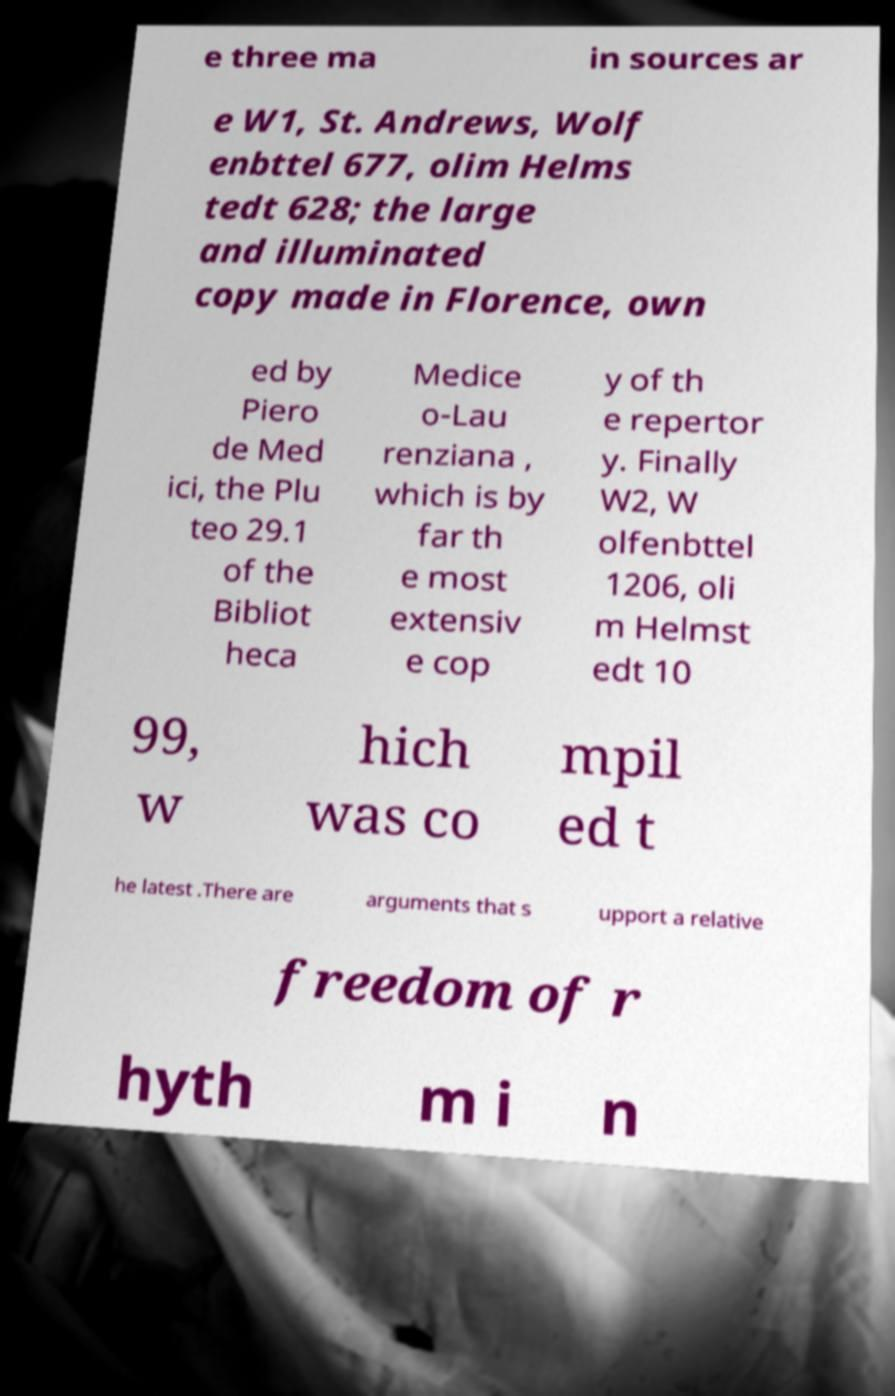Could you assist in decoding the text presented in this image and type it out clearly? e three ma in sources ar e W1, St. Andrews, Wolf enbttel 677, olim Helms tedt 628; the large and illuminated copy made in Florence, own ed by Piero de Med ici, the Plu teo 29.1 of the Bibliot heca Medice o-Lau renziana , which is by far th e most extensiv e cop y of th e repertor y. Finally W2, W olfenbttel 1206, oli m Helmst edt 10 99, w hich was co mpil ed t he latest .There are arguments that s upport a relative freedom of r hyth m i n 